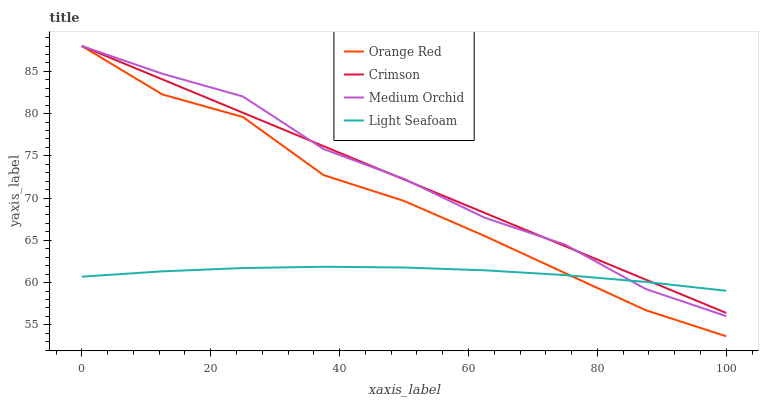Does Light Seafoam have the minimum area under the curve?
Answer yes or no. Yes. Does Medium Orchid have the maximum area under the curve?
Answer yes or no. Yes. Does Orange Red have the minimum area under the curve?
Answer yes or no. No. Does Orange Red have the maximum area under the curve?
Answer yes or no. No. Is Crimson the smoothest?
Answer yes or no. Yes. Is Orange Red the roughest?
Answer yes or no. Yes. Is Medium Orchid the smoothest?
Answer yes or no. No. Is Medium Orchid the roughest?
Answer yes or no. No. Does Medium Orchid have the lowest value?
Answer yes or no. No. Does Orange Red have the highest value?
Answer yes or no. Yes. Does Light Seafoam have the highest value?
Answer yes or no. No. Does Orange Red intersect Crimson?
Answer yes or no. Yes. Is Orange Red less than Crimson?
Answer yes or no. No. Is Orange Red greater than Crimson?
Answer yes or no. No. 